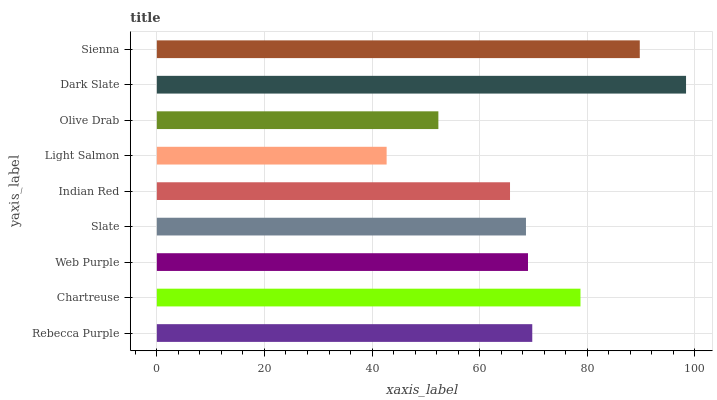Is Light Salmon the minimum?
Answer yes or no. Yes. Is Dark Slate the maximum?
Answer yes or no. Yes. Is Chartreuse the minimum?
Answer yes or no. No. Is Chartreuse the maximum?
Answer yes or no. No. Is Chartreuse greater than Rebecca Purple?
Answer yes or no. Yes. Is Rebecca Purple less than Chartreuse?
Answer yes or no. Yes. Is Rebecca Purple greater than Chartreuse?
Answer yes or no. No. Is Chartreuse less than Rebecca Purple?
Answer yes or no. No. Is Web Purple the high median?
Answer yes or no. Yes. Is Web Purple the low median?
Answer yes or no. Yes. Is Olive Drab the high median?
Answer yes or no. No. Is Slate the low median?
Answer yes or no. No. 